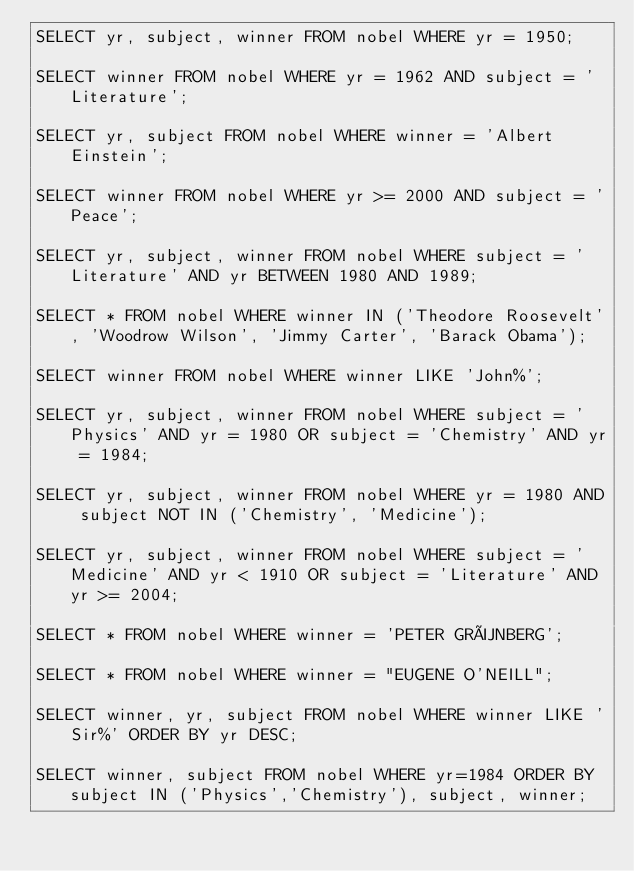<code> <loc_0><loc_0><loc_500><loc_500><_SQL_>SELECT yr, subject, winner FROM nobel WHERE yr = 1950;

SELECT winner FROM nobel WHERE yr = 1962 AND subject = 'Literature';

SELECT yr, subject FROM nobel WHERE winner = 'Albert Einstein';

SELECT winner FROM nobel WHERE yr >= 2000 AND subject = 'Peace';

SELECT yr, subject, winner FROM nobel WHERE subject = 'Literature' AND yr BETWEEN 1980 AND 1989;

SELECT * FROM nobel WHERE winner IN ('Theodore Roosevelt', 'Woodrow Wilson', 'Jimmy Carter', 'Barack Obama');

SELECT winner FROM nobel WHERE winner LIKE 'John%';

SELECT yr, subject, winner FROM nobel WHERE subject = 'Physics' AND yr = 1980 OR subject = 'Chemistry' AND yr = 1984;

SELECT yr, subject, winner FROM nobel WHERE yr = 1980 AND subject NOT IN ('Chemistry', 'Medicine');

SELECT yr, subject, winner FROM nobel WHERE subject = 'Medicine' AND yr < 1910 OR subject = 'Literature' AND yr >= 2004;

SELECT * FROM nobel WHERE winner = 'PETER GRÜNBERG';

SELECT * FROM nobel WHERE winner = "EUGENE O'NEILL";

SELECT winner, yr, subject FROM nobel WHERE winner LIKE 'Sir%' ORDER BY yr DESC;

SELECT winner, subject FROM nobel WHERE yr=1984 ORDER BY subject IN ('Physics','Chemistry'), subject, winner;</code> 